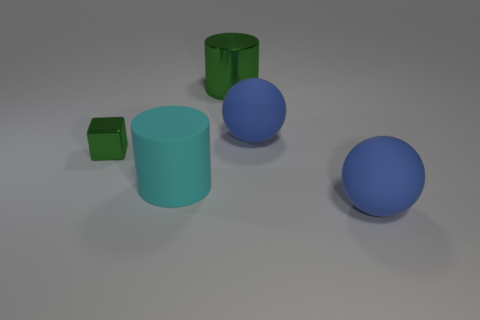Add 5 big gray metallic blocks. How many objects exist? 10 Subtract all balls. How many objects are left? 3 Subtract 1 green cylinders. How many objects are left? 4 Subtract all small metal cubes. Subtract all big green metallic things. How many objects are left? 3 Add 1 metal blocks. How many metal blocks are left? 2 Add 1 tiny brown cubes. How many tiny brown cubes exist? 1 